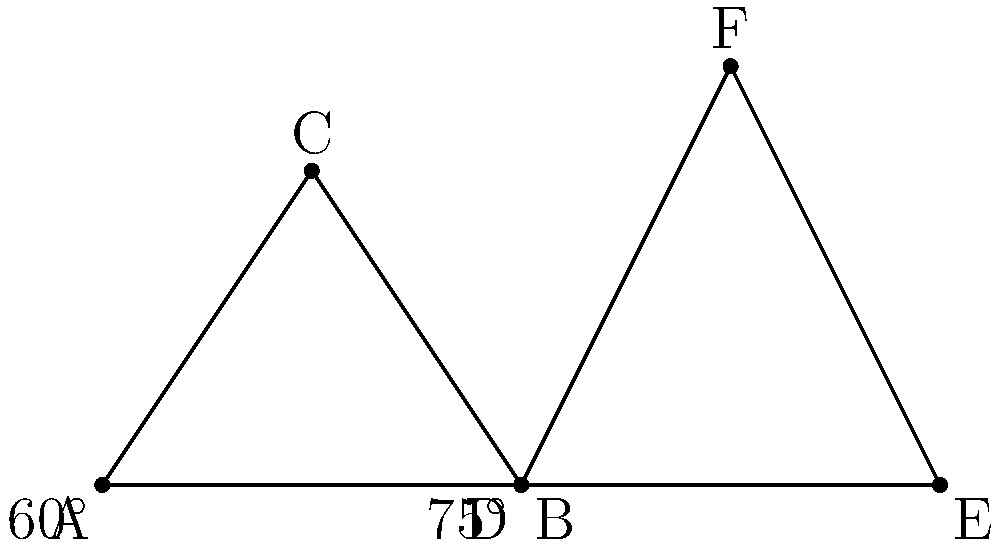Consider two tennis players' serve motions represented by triangles ABC and DEF. If the angle at A is 60° and the angle at D is 75°, which player's serve motion has a greater vertical component, assuming the base of each triangle represents the horizontal plane? To determine which serve motion has a greater vertical component, we need to compare the heights of the two triangles relative to their bases. Let's analyze this step-by-step:

1) In a triangle, a larger angle opposite the base corresponds to a greater height.

2) Triangle ABC:
   - Base angle: 60°
   - Complementary angle: 90° - 60° = 30°

3) Triangle DEF:
   - Base angle: 75°
   - Complementary angle: 90° - 75° = 15°

4) The height of each triangle is determined by the sine of the base angle:
   - For ABC: $h_{ABC} \propto \sin(60°)$
   - For DEF: $h_{DEF} \propto \sin(75°)$

5) We know that $\sin(75°) > \sin(60°)$:
   - $\sin(60°) \approx 0.866$
   - $\sin(75°) \approx 0.966$

6) Therefore, triangle DEF has a greater height relative to its base compared to triangle ABC.

7) A greater relative height indicates a larger vertical component in the serve motion.

Thus, the player represented by triangle DEF has a serve motion with a greater vertical component.
Answer: Player DEF 